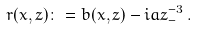<formula> <loc_0><loc_0><loc_500><loc_500>r ( x , z ) \colon = b ( x , z ) - i { \sl a z } ^ { - 3 } _ { - } \, .</formula> 